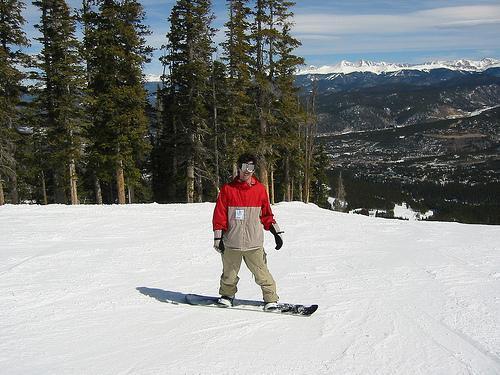How many people are there?
Give a very brief answer. 1. 